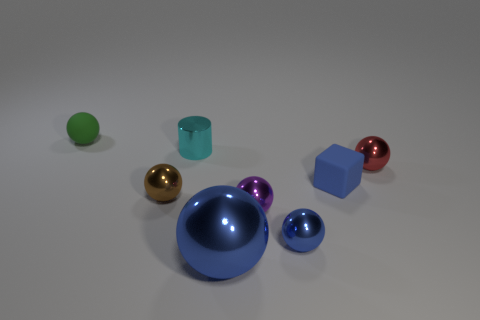What is the shape of the small matte object that is the same color as the large sphere?
Your response must be concise. Cube. Is the size of the brown metal sphere the same as the red object?
Keep it short and to the point. Yes. What number of objects are either objects in front of the small green matte thing or metallic things that are on the right side of the cylinder?
Your response must be concise. 7. There is a ball to the right of the matte object in front of the green matte object; what is it made of?
Provide a short and direct response. Metal. How many other things are there of the same material as the blue block?
Your response must be concise. 1. Is the small brown shiny thing the same shape as the red metal object?
Provide a short and direct response. Yes. What size is the matte thing in front of the matte ball?
Offer a terse response. Small. There is a purple metallic sphere; does it have the same size as the shiny sphere right of the tiny rubber block?
Give a very brief answer. Yes. Is the number of cyan metallic cylinders that are right of the cyan metal cylinder less than the number of tiny brown metal cylinders?
Ensure brevity in your answer.  No. There is a large thing that is the same shape as the small purple thing; what is it made of?
Ensure brevity in your answer.  Metal. 